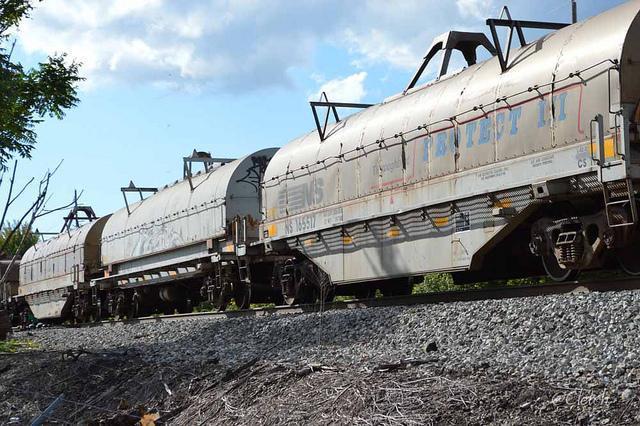How many train carts do you see?
Give a very brief answer. 3. How many big chairs are in the image?
Give a very brief answer. 0. 